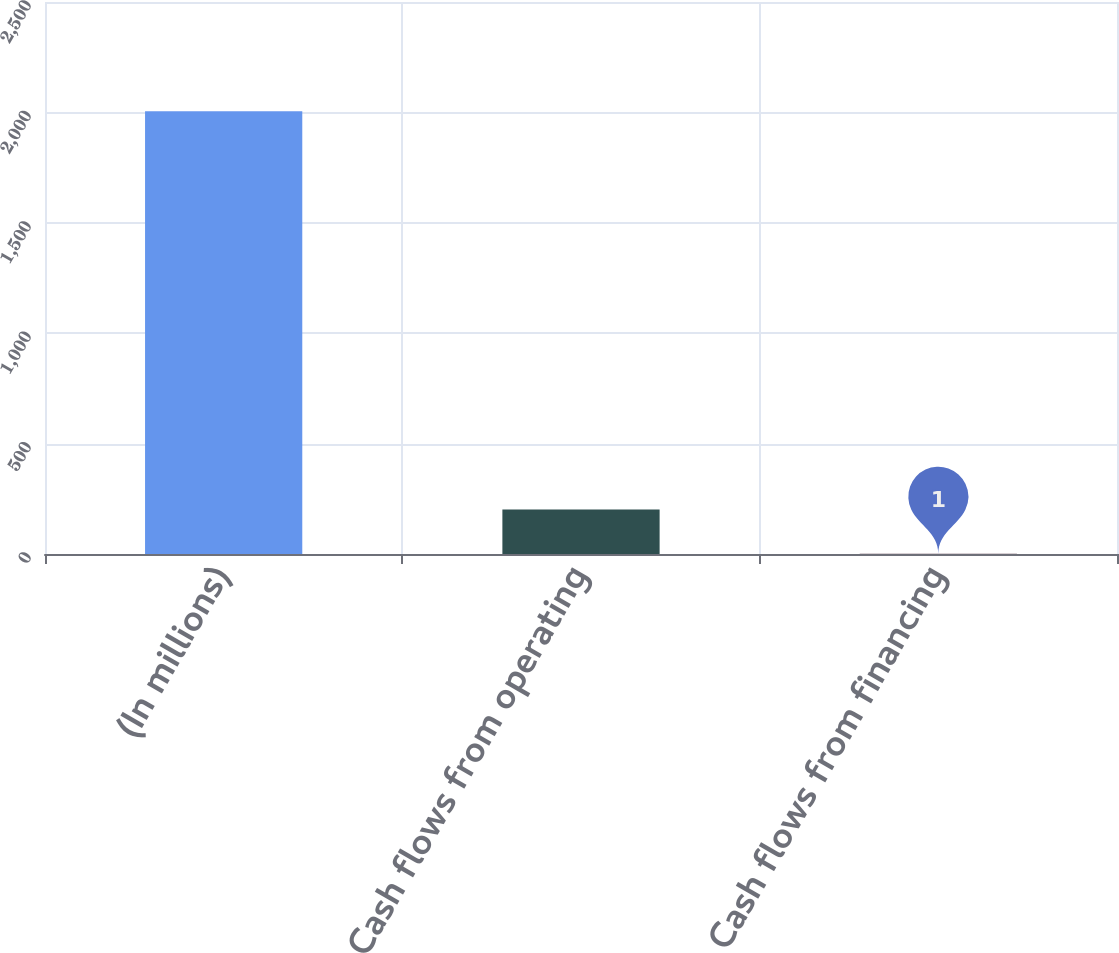<chart> <loc_0><loc_0><loc_500><loc_500><bar_chart><fcel>(In millions)<fcel>Cash flows from operating<fcel>Cash flows from financing<nl><fcel>2005<fcel>201.4<fcel>1<nl></chart> 